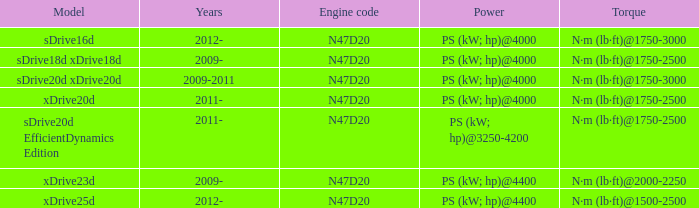Which version has the n·m (lb·ft)@1500-2500 torque characteristic? Xdrive25d. 